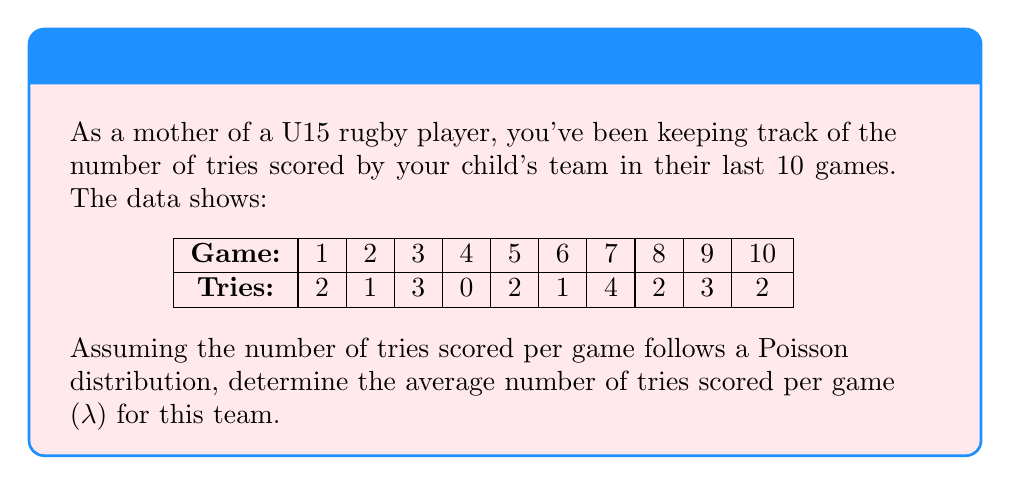What is the answer to this math problem? To determine the average number of tries scored per game (λ) using a Poisson distribution, we follow these steps:

1. Calculate the total number of tries:
   $\text{Total tries} = 2 + 1 + 3 + 0 + 2 + 1 + 4 + 2 + 3 + 2 = 20$

2. Calculate the number of games:
   $\text{Number of games} = 10$

3. Calculate the average (λ):
   $$\lambda = \frac{\text{Total tries}}{\text{Number of games}} = \frac{20}{10} = 2$$

In a Poisson distribution, the parameter λ represents both the average and the variance of the distribution. Therefore, the average number of tries scored per game is 2.

To verify this fits a Poisson distribution, we could compare the observed frequencies with the expected frequencies using a chi-square goodness-of-fit test, but that's beyond the scope of this question.
Answer: $\lambda = 2$ tries per game 